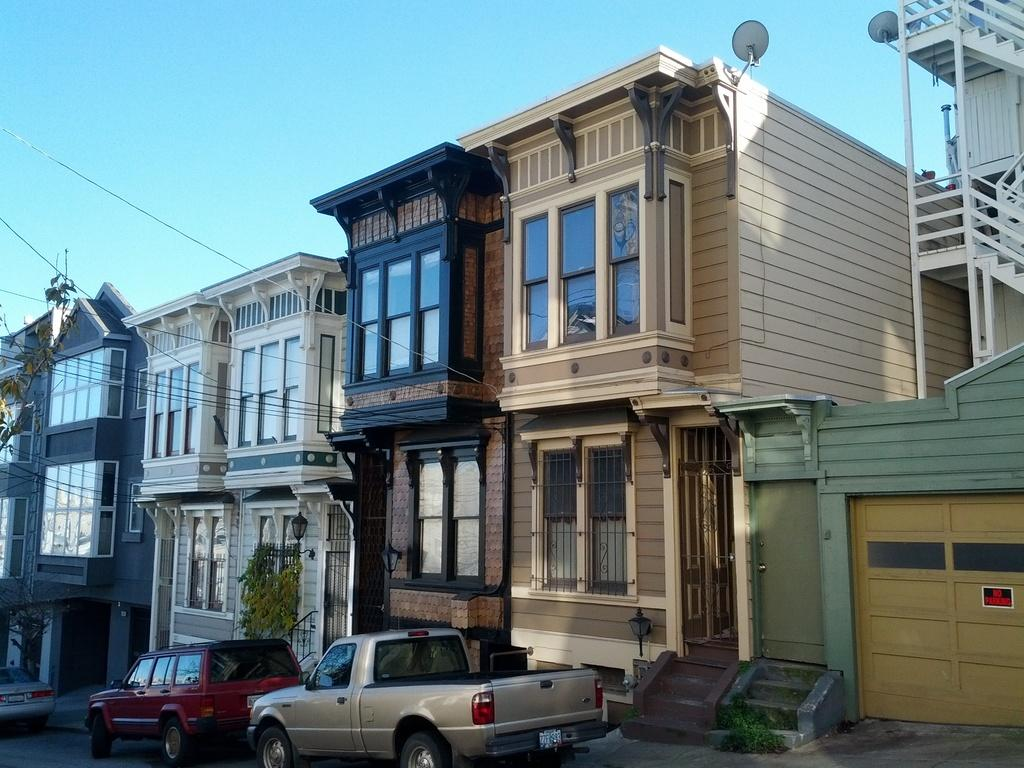What type of structures can be seen in the image? There are buildings in the image. What type of vehicles are present in the image? There are cars in the image. What is visible at the top of the image? The sky is visible at the top of the image. Can you hear the sound of the ocean in the image? There is no reference to the ocean or any sounds in the image, so it's not possible to determine if the sound of the ocean can be heard. 